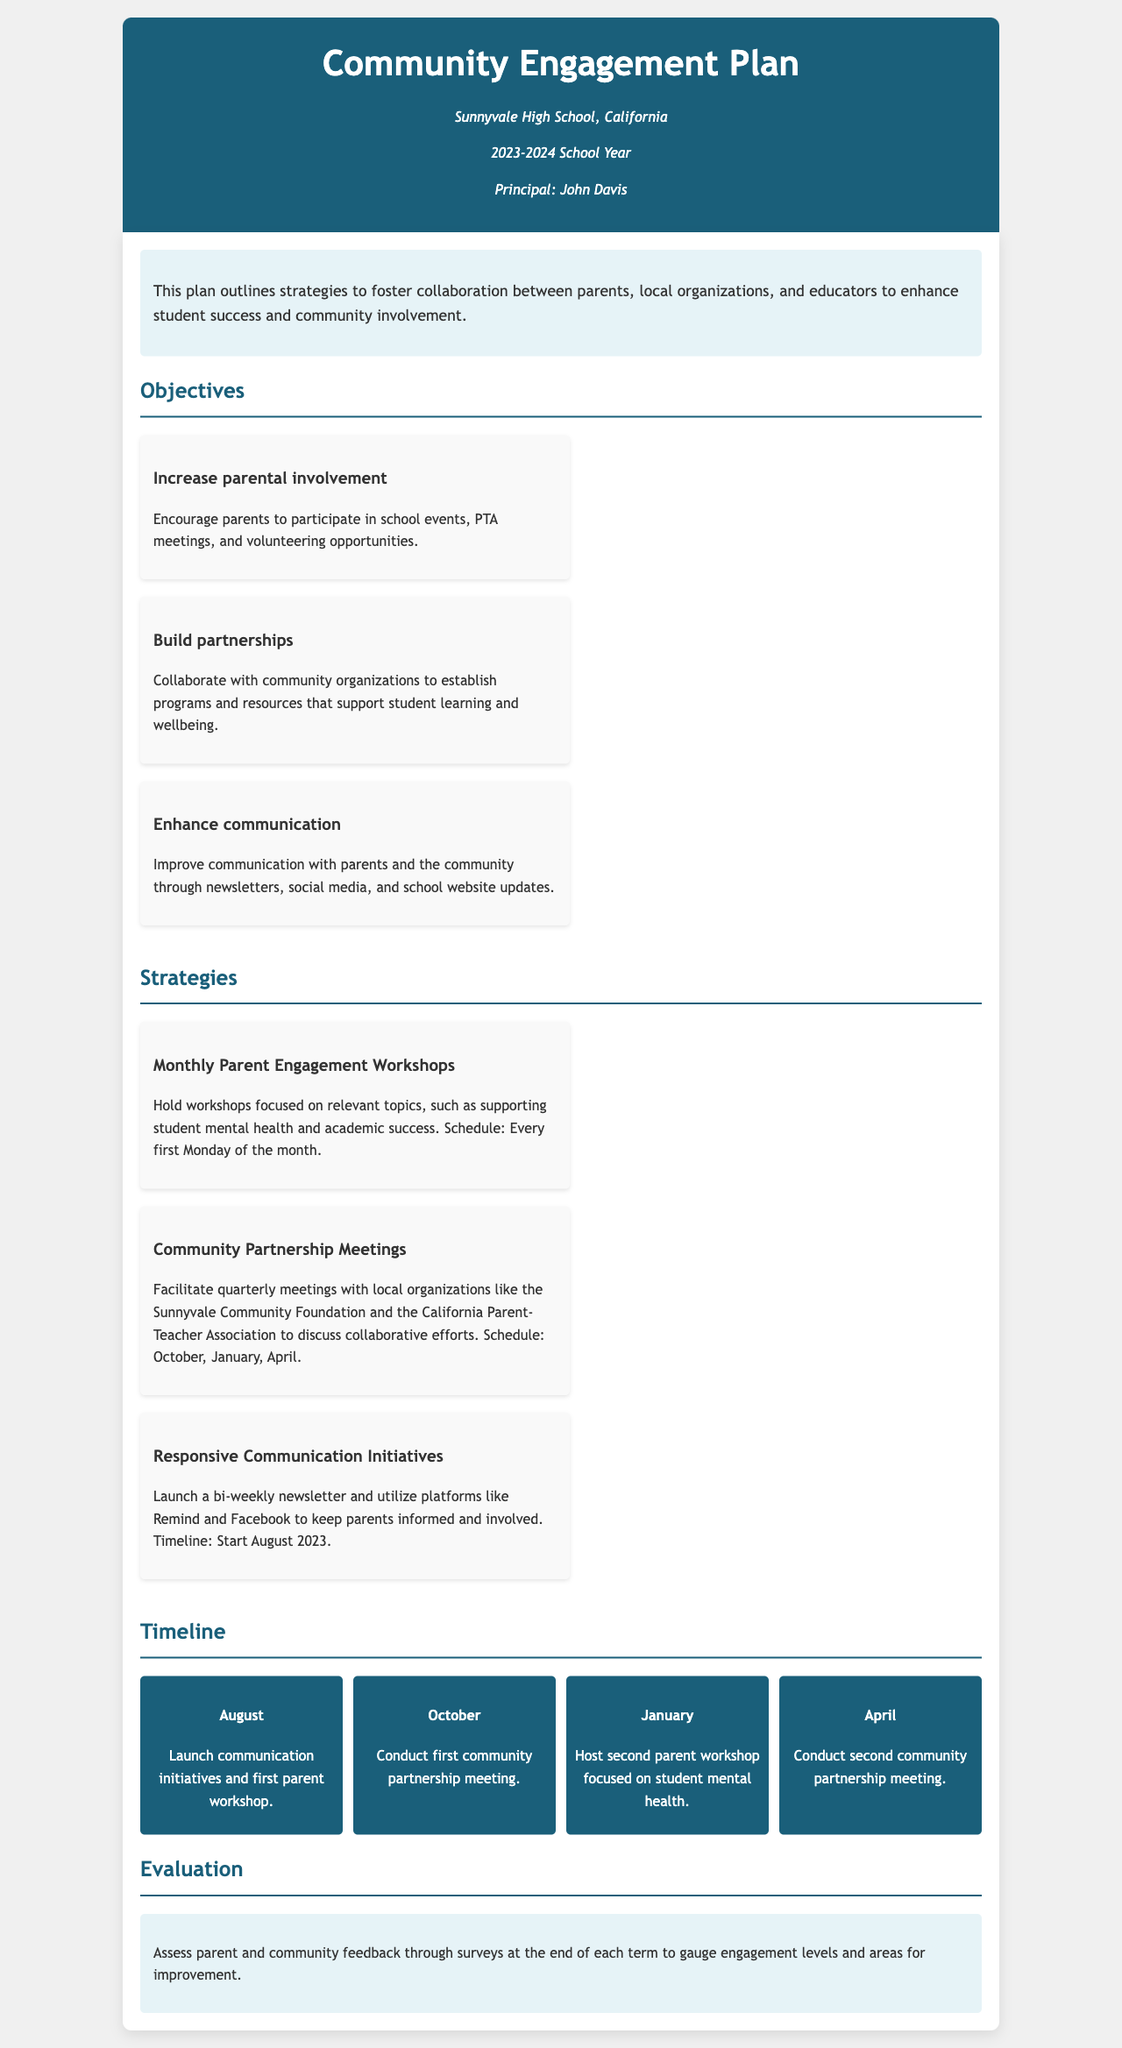What is the title of the document? The title is the main heading of the document, which outlines the purpose of the plan.
Answer: Community Engagement Plan 2023-2024 Who is the principal of Sunnyvale High School? The principal's name is mentioned under the school information section of the document.
Answer: John Davis When will the first community partnership meeting be held? The date for the first community partnership meeting is outlined in the timeline section of the document.
Answer: October What is one objective of the Community Engagement Plan? Objectives are listed in a specific section and focus on different aspects of community engagement.
Answer: Increase parental involvement What is the frequency of the parent engagement workshops? The schedule for the workshops is noted, indicating how often they will occur throughout the year.
Answer: Monthly Which organization will participate in quarterly meetings? A specific example of a local organization is mentioned in the strategies section of the document.
Answer: Sunnyvale Community Foundation What method will be used for communication with parents? The document lists various platforms used for communication with parents under a specific strategy.
Answer: Newsletter How will the plan assess its effectiveness? The evaluation method at the end of the document provides a way to measure engagement success.
Answer: Surveys 